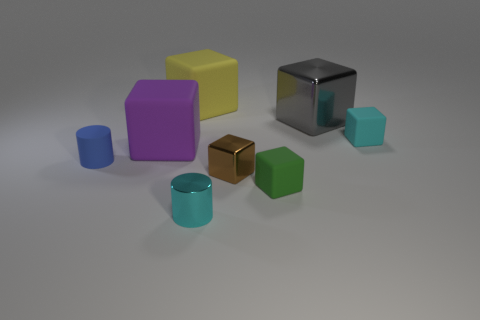Is the number of brown things greater than the number of big things?
Provide a succinct answer. No. What color is the cube that is in front of the small shiny thing right of the cylinder to the right of the yellow block?
Make the answer very short. Green. The small cylinder that is made of the same material as the gray cube is what color?
Make the answer very short. Cyan. Is there any other thing that has the same size as the cyan matte block?
Keep it short and to the point. Yes. How many objects are either rubber blocks behind the cyan block or blocks that are right of the small cyan metallic object?
Your answer should be very brief. 5. Do the cylinder on the right side of the small blue matte object and the rubber thing that is in front of the tiny blue thing have the same size?
Offer a very short reply. Yes. There is another object that is the same shape as the blue object; what is its color?
Give a very brief answer. Cyan. Are there any other things that are the same shape as the purple rubber object?
Offer a terse response. Yes. Are there more gray metallic things that are in front of the purple rubber object than blue matte cylinders that are in front of the cyan metallic object?
Ensure brevity in your answer.  No. What size is the cylinder that is behind the cyan object that is left of the tiny matte block that is behind the rubber cylinder?
Offer a terse response. Small. 